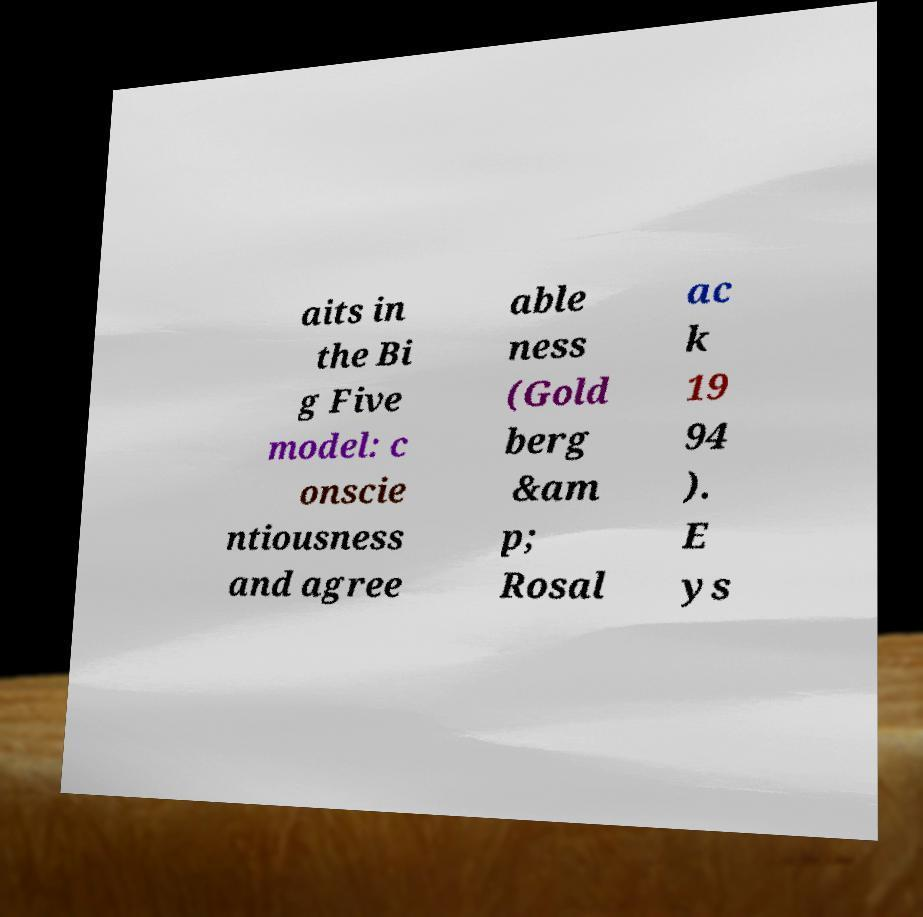Please identify and transcribe the text found in this image. aits in the Bi g Five model: c onscie ntiousness and agree able ness (Gold berg &am p; Rosal ac k 19 94 ). E ys 